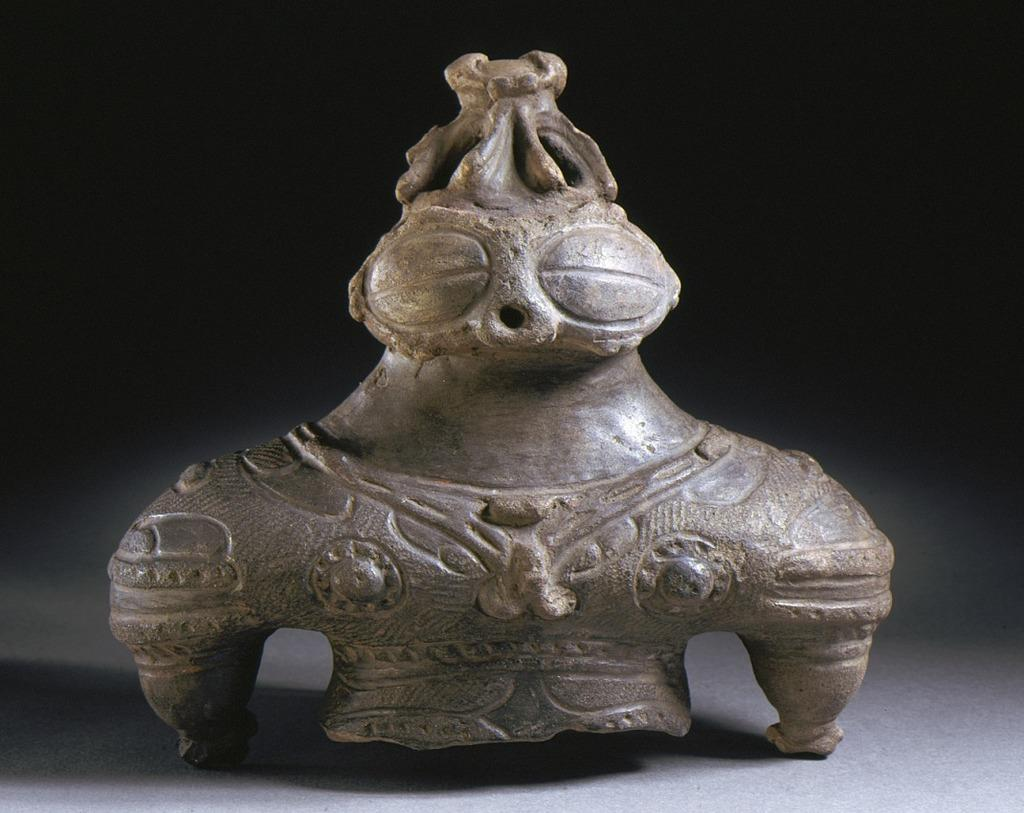What is the main subject of the image? There is a mini sculpture in the image. What can be seen in the background of the image? The background of the image is black. What advice does the mini sculpture give to the visitor in the image? There is no visitor present in the image, and the mini sculpture does not give advice. 